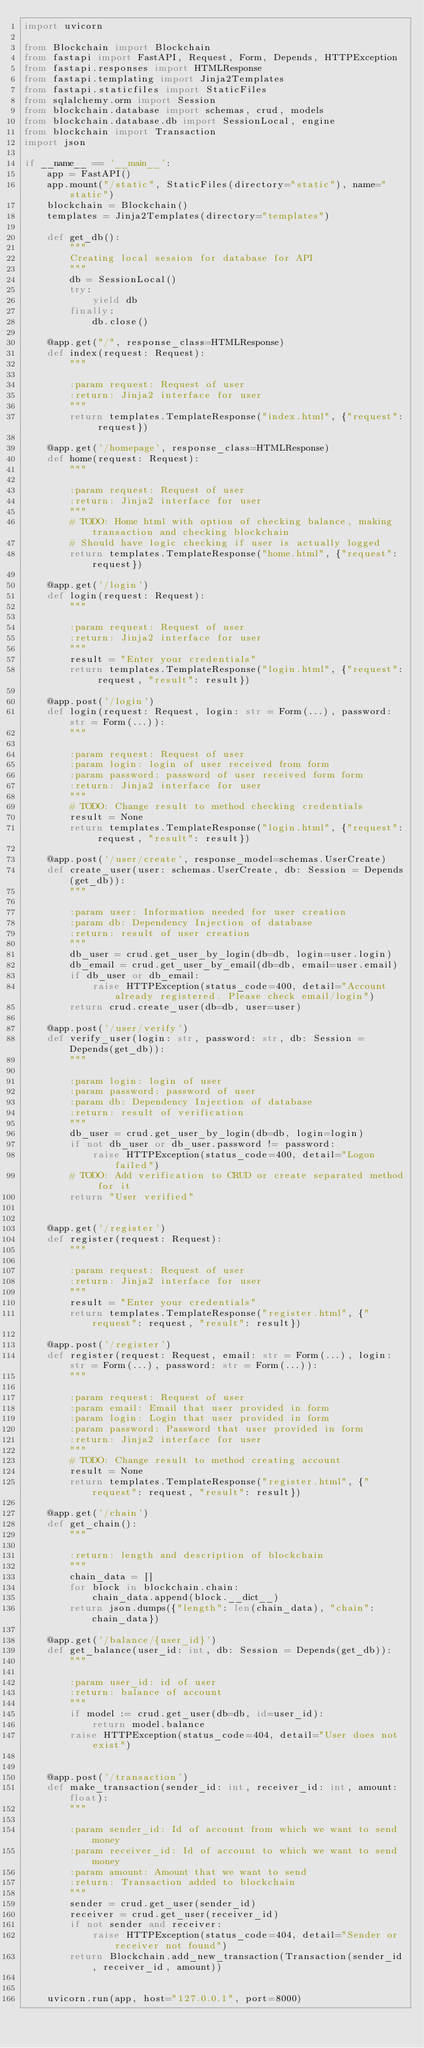<code> <loc_0><loc_0><loc_500><loc_500><_Python_>import uvicorn

from Blockchain import Blockchain
from fastapi import FastAPI, Request, Form, Depends, HTTPException
from fastapi.responses import HTMLResponse
from fastapi.templating import Jinja2Templates
from fastapi.staticfiles import StaticFiles
from sqlalchemy.orm import Session
from blockchain.database import schemas, crud, models
from blockchain.database.db import SessionLocal, engine
from blockchain import Transaction
import json

if __name__ == '__main__':
    app = FastAPI()
    app.mount("/static", StaticFiles(directory="static"), name="static")
    blockchain = Blockchain()
    templates = Jinja2Templates(directory="templates")

    def get_db():
        """
        Creating local session for database for API
        """
        db = SessionLocal()
        try:
            yield db
        finally:
            db.close()

    @app.get("/", response_class=HTMLResponse)
    def index(request: Request):
        """

        :param request: Request of user
        :return: Jinja2 interface for user
        """
        return templates.TemplateResponse("index.html", {"request": request})

    @app.get('/homepage', response_class=HTMLResponse)
    def home(request: Request):
        """

        :param request: Request of user
        :return: Jinja2 interface for user
        """
        # TODO: Home html with option of checking balance, making transaction and checking blockchain
        # Should have logic checking if user is actually logged
        return templates.TemplateResponse("home.html", {"request": request})

    @app.get('/login')
    def login(request: Request):
        """

        :param request: Request of user
        :return: Jinja2 interface for user
        """
        result = "Enter your credentials"
        return templates.TemplateResponse("login.html", {"request": request, "result": result})

    @app.post('/login')
    def login(request: Request, login: str = Form(...), password: str = Form(...)):
        """

        :param request: Request of user
        :param login: login of user received from form
        :param password: password of user received form form
        :return: Jinja2 interface for user
        """
        # TODO: Change result to method checking credentials
        result = None
        return templates.TemplateResponse("login.html", {"request": request, "result": result})

    @app.post('/user/create', response_model=schemas.UserCreate)
    def create_user(user: schemas.UserCreate, db: Session = Depends(get_db)):
        """

        :param user: Information needed for user creation
        :param db: Dependency Injection of database
        :return: result of user creation
        """
        db_user = crud.get_user_by_login(db=db, login=user.login)
        db_email = crud.get_user_by_email(db=db, email=user.email)
        if db_user or db_email:
            raise HTTPException(status_code=400, detail="Account already registered. Please check email/login")
        return crud.create_user(db=db, user=user)

    @app.post('/user/verify')
    def verify_user(login: str, password: str, db: Session = Depends(get_db)):
        """

        :param login: login of user
        :param password: password of user
        :param db: Dependency Injection of database
        :return: result of verification
        """
        db_user = crud.get_user_by_login(db=db, login=login)
        if not db_user or db_user.password != password:
            raise HTTPException(status_code=400, detail="Logon failed")
        # TODO: Add verification to CRUD or create separated method for it
        return "User verified"


    @app.get('/register')
    def register(request: Request):
        """

        :param request: Request of user
        :return: Jinja2 interface for user
        """
        result = "Enter your credentials"
        return templates.TemplateResponse("register.html", {"request": request, "result": result})

    @app.post('/register')
    def register(request: Request, email: str = Form(...), login: str = Form(...), password: str = Form(...)):
        """

        :param request: Request of user
        :param email: Email that user provided in form
        :param login: Login that user provided in form
        :param password: Password that user provided in form
        :return: Jinja2 interface for user
        """
        # TODO: Change result to method creating account
        result = None
        return templates.TemplateResponse("register.html", {"request": request, "result": result})

    @app.get('/chain')
    def get_chain():
        """

        :return: length and description of blockchain
        """
        chain_data = []
        for block in blockchain.chain:
            chain_data.append(block.__dict__)
        return json.dumps({"length": len(chain_data), "chain": chain_data})

    @app.get('/balance/{user_id}')
    def get_balance(user_id: int, db: Session = Depends(get_db)):
        """

        :param user_id: id of user
        :return: balance of account
        """
        if model := crud.get_user(db=db, id=user_id):
            return model.balance
        raise HTTPException(status_code=404, detail="User does not exist")


    @app.post('/transaction')
    def make_transaction(sender_id: int, receiver_id: int, amount: float):
        """

        :param sender_id: Id of account from which we want to send money
        :param receiver_id: Id of account to which we want to send money
        :param amount: Amount that we want to send
        :return: Transaction added to blockchain
        """
        sender = crud.get_user(sender_id)
        receiver = crud.get_user(receiver_id)
        if not sender and receiver:
            raise HTTPException(status_code=404, detail="Sender or receiver not found")
        return Blockchain.add_new_transaction(Transaction(sender_id, receiver_id, amount))


    uvicorn.run(app, host="127.0.0.1", port=8000)</code> 